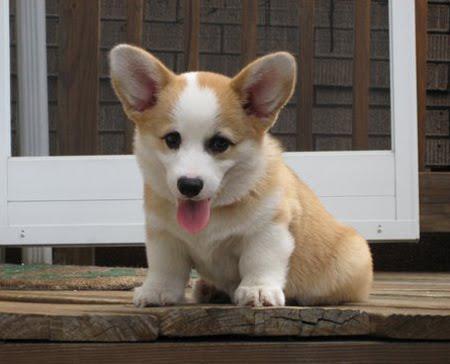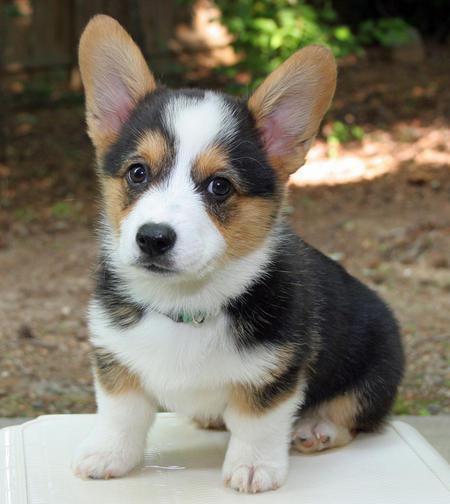The first image is the image on the left, the second image is the image on the right. Considering the images on both sides, is "The righthand image contains a single dog, which is tri-colored and sitting upright, with its mouth closed." valid? Answer yes or no. Yes. The first image is the image on the left, the second image is the image on the right. Examine the images to the left and right. Is the description "There is exactly three puppies." accurate? Answer yes or no. No. 